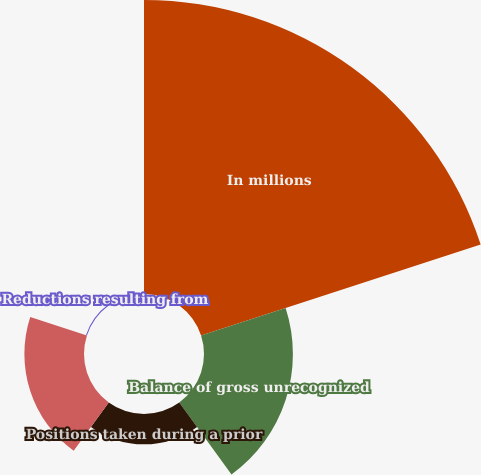<chart> <loc_0><loc_0><loc_500><loc_500><pie_chart><fcel>In millions<fcel>Balance of gross unrecognized<fcel>Positions taken during a prior<fcel>Settlements with taxing<fcel>Reductions resulting from<nl><fcel>62.04%<fcel>18.76%<fcel>6.4%<fcel>12.58%<fcel>0.22%<nl></chart> 